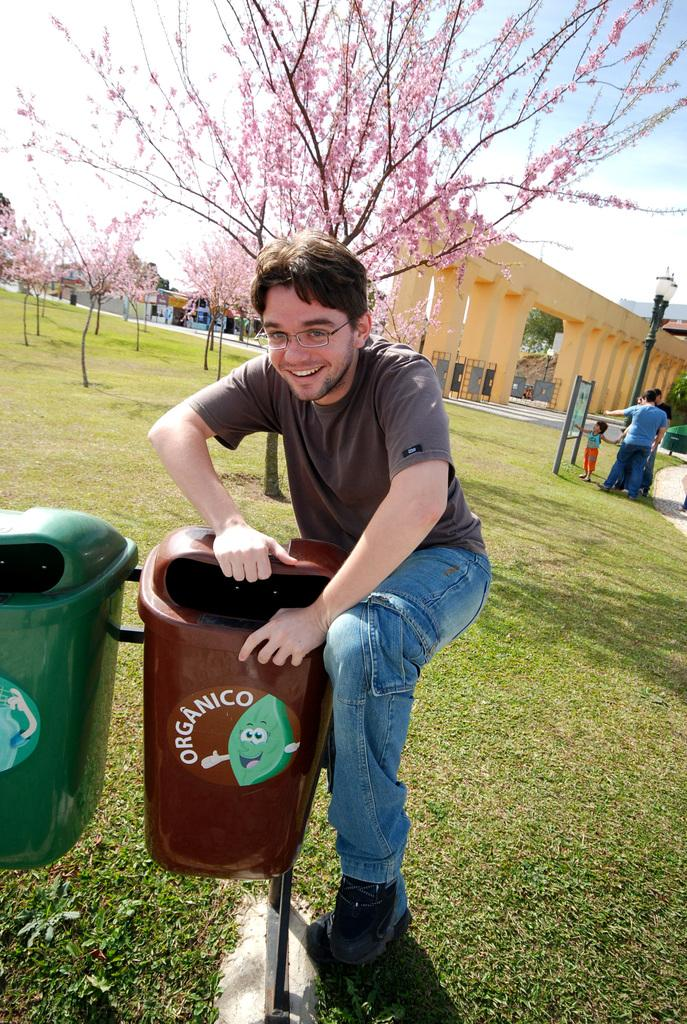<image>
Render a clear and concise summary of the photo. A guy holds a bin open that has the word organico on the side. 